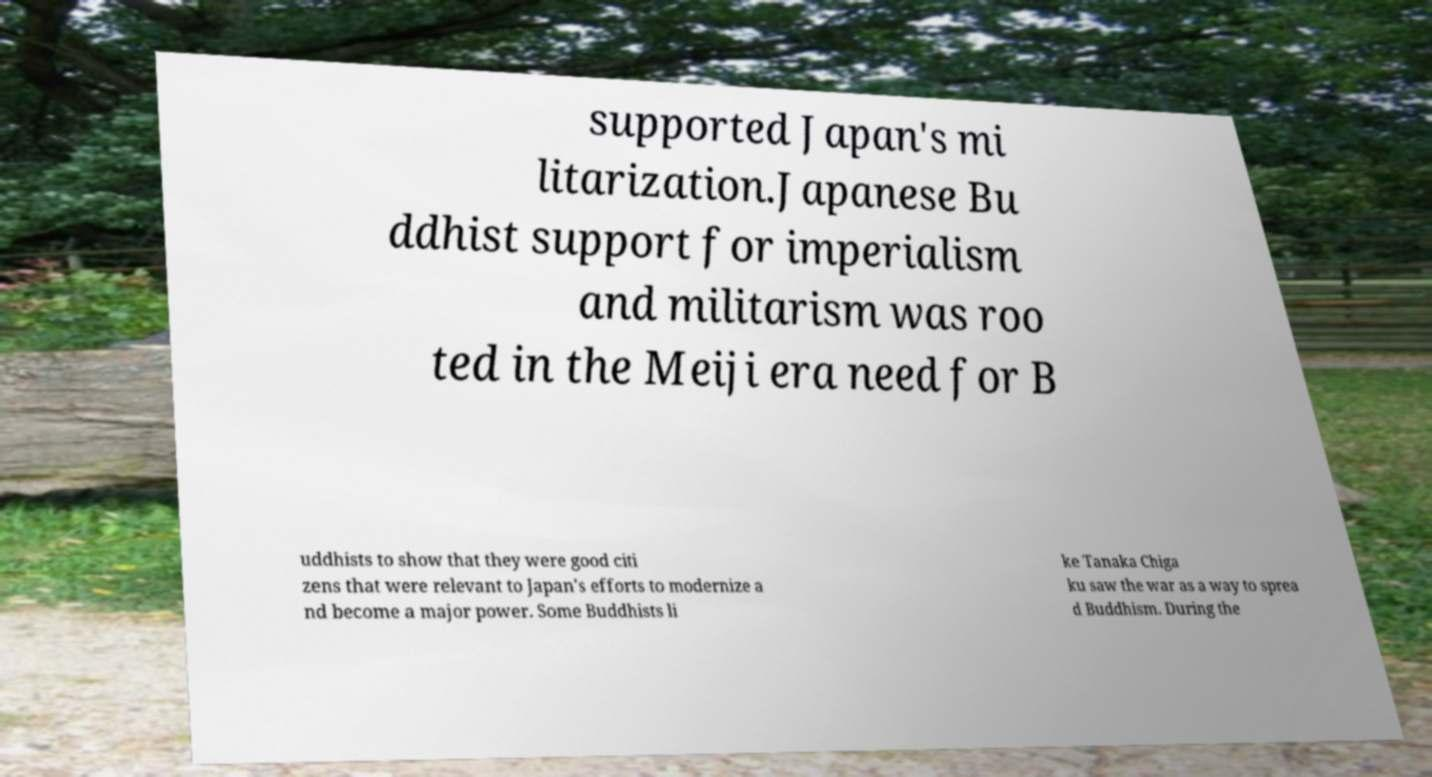Please read and relay the text visible in this image. What does it say? supported Japan's mi litarization.Japanese Bu ddhist support for imperialism and militarism was roo ted in the Meiji era need for B uddhists to show that they were good citi zens that were relevant to Japan's efforts to modernize a nd become a major power. Some Buddhists li ke Tanaka Chiga ku saw the war as a way to sprea d Buddhism. During the 